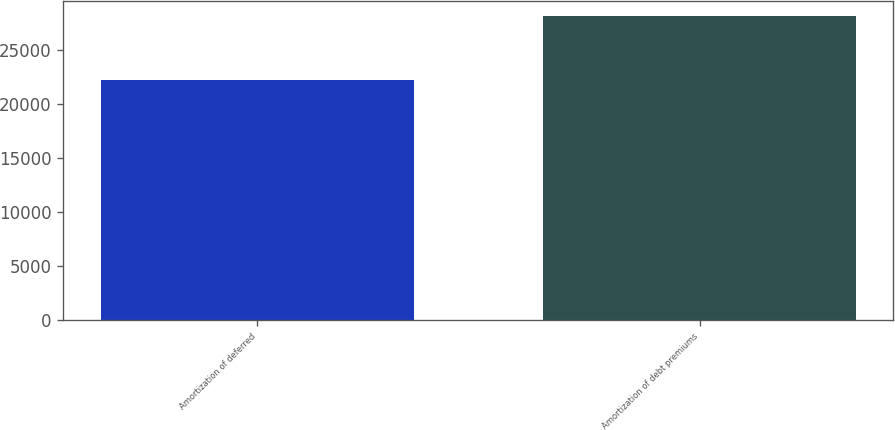Convert chart to OTSL. <chart><loc_0><loc_0><loc_500><loc_500><bar_chart><fcel>Amortization of deferred<fcel>Amortization of debt premiums<nl><fcel>22259<fcel>28163<nl></chart> 